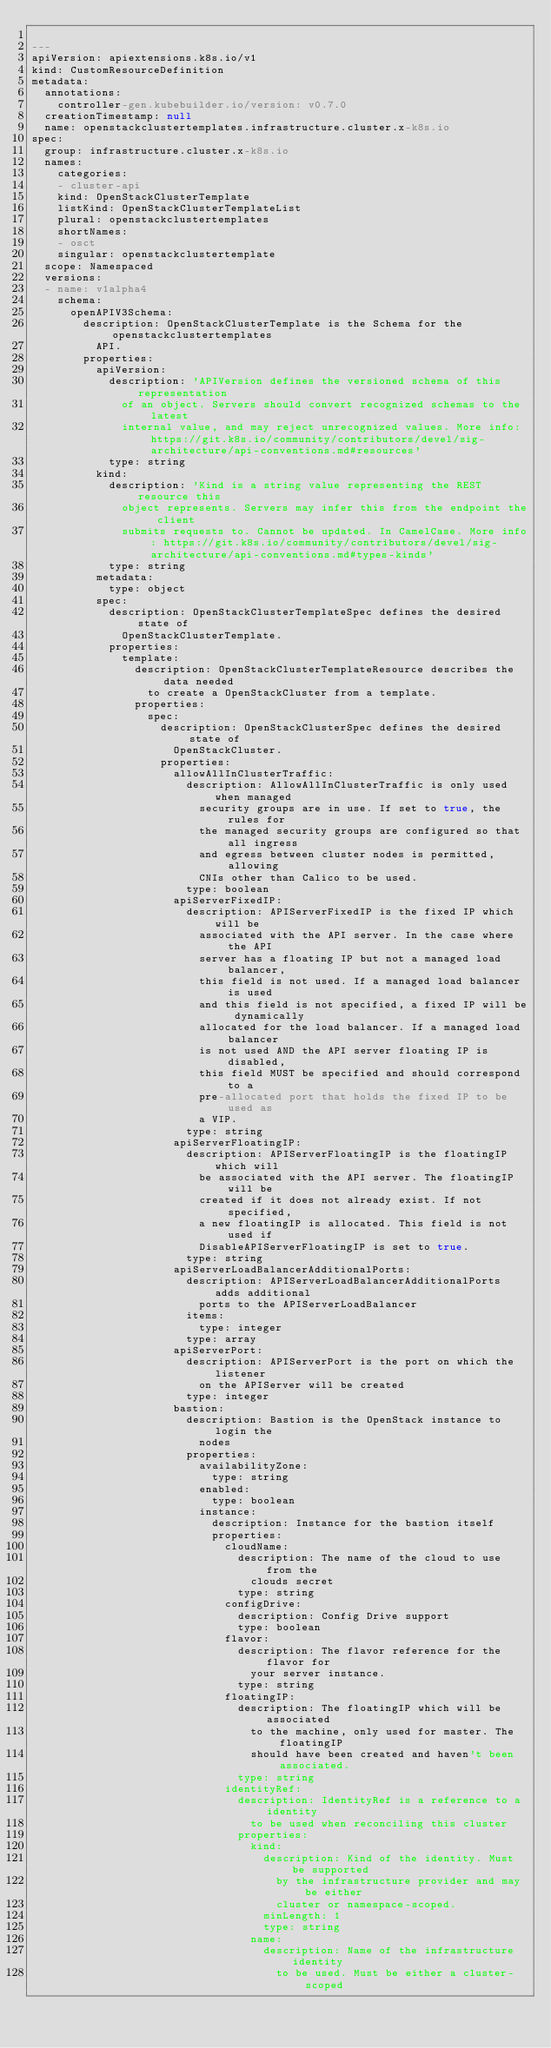<code> <loc_0><loc_0><loc_500><loc_500><_YAML_>
---
apiVersion: apiextensions.k8s.io/v1
kind: CustomResourceDefinition
metadata:
  annotations:
    controller-gen.kubebuilder.io/version: v0.7.0
  creationTimestamp: null
  name: openstackclustertemplates.infrastructure.cluster.x-k8s.io
spec:
  group: infrastructure.cluster.x-k8s.io
  names:
    categories:
    - cluster-api
    kind: OpenStackClusterTemplate
    listKind: OpenStackClusterTemplateList
    plural: openstackclustertemplates
    shortNames:
    - osct
    singular: openstackclustertemplate
  scope: Namespaced
  versions:
  - name: v1alpha4
    schema:
      openAPIV3Schema:
        description: OpenStackClusterTemplate is the Schema for the openstackclustertemplates
          API.
        properties:
          apiVersion:
            description: 'APIVersion defines the versioned schema of this representation
              of an object. Servers should convert recognized schemas to the latest
              internal value, and may reject unrecognized values. More info: https://git.k8s.io/community/contributors/devel/sig-architecture/api-conventions.md#resources'
            type: string
          kind:
            description: 'Kind is a string value representing the REST resource this
              object represents. Servers may infer this from the endpoint the client
              submits requests to. Cannot be updated. In CamelCase. More info: https://git.k8s.io/community/contributors/devel/sig-architecture/api-conventions.md#types-kinds'
            type: string
          metadata:
            type: object
          spec:
            description: OpenStackClusterTemplateSpec defines the desired state of
              OpenStackClusterTemplate.
            properties:
              template:
                description: OpenStackClusterTemplateResource describes the data needed
                  to create a OpenStackCluster from a template.
                properties:
                  spec:
                    description: OpenStackClusterSpec defines the desired state of
                      OpenStackCluster.
                    properties:
                      allowAllInClusterTraffic:
                        description: AllowAllInClusterTraffic is only used when managed
                          security groups are in use. If set to true, the rules for
                          the managed security groups are configured so that all ingress
                          and egress between cluster nodes is permitted, allowing
                          CNIs other than Calico to be used.
                        type: boolean
                      apiServerFixedIP:
                        description: APIServerFixedIP is the fixed IP which will be
                          associated with the API server. In the case where the API
                          server has a floating IP but not a managed load balancer,
                          this field is not used. If a managed load balancer is used
                          and this field is not specified, a fixed IP will be dynamically
                          allocated for the load balancer. If a managed load balancer
                          is not used AND the API server floating IP is disabled,
                          this field MUST be specified and should correspond to a
                          pre-allocated port that holds the fixed IP to be used as
                          a VIP.
                        type: string
                      apiServerFloatingIP:
                        description: APIServerFloatingIP is the floatingIP which will
                          be associated with the API server. The floatingIP will be
                          created if it does not already exist. If not specified,
                          a new floatingIP is allocated. This field is not used if
                          DisableAPIServerFloatingIP is set to true.
                        type: string
                      apiServerLoadBalancerAdditionalPorts:
                        description: APIServerLoadBalancerAdditionalPorts adds additional
                          ports to the APIServerLoadBalancer
                        items:
                          type: integer
                        type: array
                      apiServerPort:
                        description: APIServerPort is the port on which the listener
                          on the APIServer will be created
                        type: integer
                      bastion:
                        description: Bastion is the OpenStack instance to login the
                          nodes
                        properties:
                          availabilityZone:
                            type: string
                          enabled:
                            type: boolean
                          instance:
                            description: Instance for the bastion itself
                            properties:
                              cloudName:
                                description: The name of the cloud to use from the
                                  clouds secret
                                type: string
                              configDrive:
                                description: Config Drive support
                                type: boolean
                              flavor:
                                description: The flavor reference for the flavor for
                                  your server instance.
                                type: string
                              floatingIP:
                                description: The floatingIP which will be associated
                                  to the machine, only used for master. The floatingIP
                                  should have been created and haven't been associated.
                                type: string
                              identityRef:
                                description: IdentityRef is a reference to a identity
                                  to be used when reconciling this cluster
                                properties:
                                  kind:
                                    description: Kind of the identity. Must be supported
                                      by the infrastructure provider and may be either
                                      cluster or namespace-scoped.
                                    minLength: 1
                                    type: string
                                  name:
                                    description: Name of the infrastructure identity
                                      to be used. Must be either a cluster-scoped</code> 